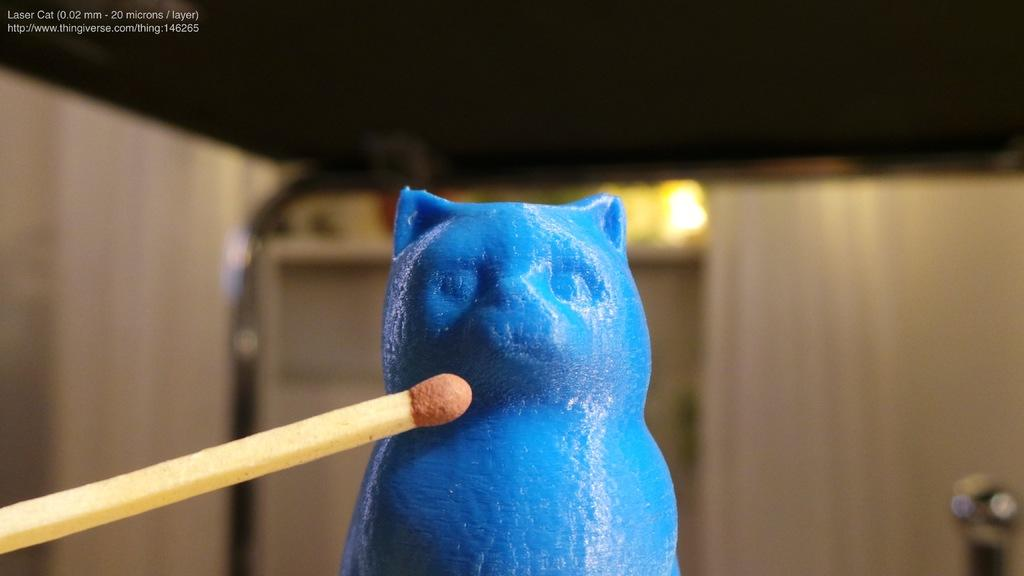What is the main object in the front of the image? There is a toy in the front of the image. Where is the match stick located in the image? The match stick is on the left side of the image. How would you describe the background of the image? The background of the image is blurry. Can you read any text in the image? Yes, there is some text visible at the left top of the image. What type of plantation can be seen in the image? There is no plantation present in the image. How steep is the slope in the image? There is no slope present in the image. 